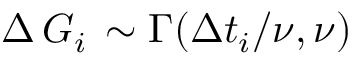Convert formula to latex. <formula><loc_0><loc_0><loc_500><loc_500>\Delta \, G _ { i } \, \sim \Gamma ( \Delta t _ { i } / \nu , \nu )</formula> 